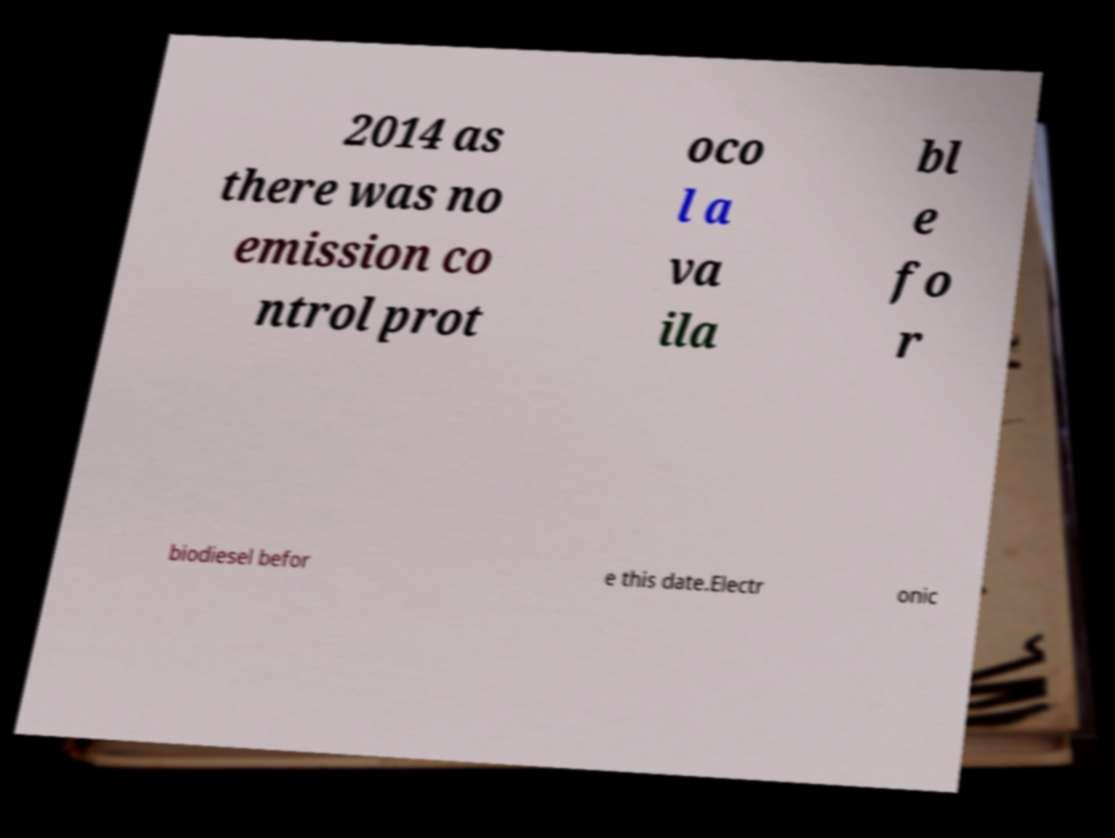Could you assist in decoding the text presented in this image and type it out clearly? 2014 as there was no emission co ntrol prot oco l a va ila bl e fo r biodiesel befor e this date.Electr onic 